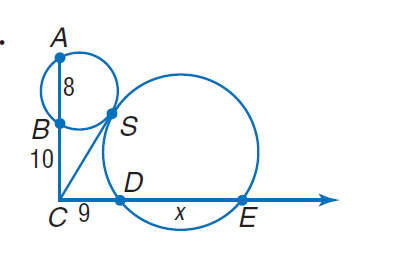Question: Find x. Round to the nearest tenth, if necessary.
Choices:
A. 8
B. 9
C. 10
D. 11
Answer with the letter. Answer: D 